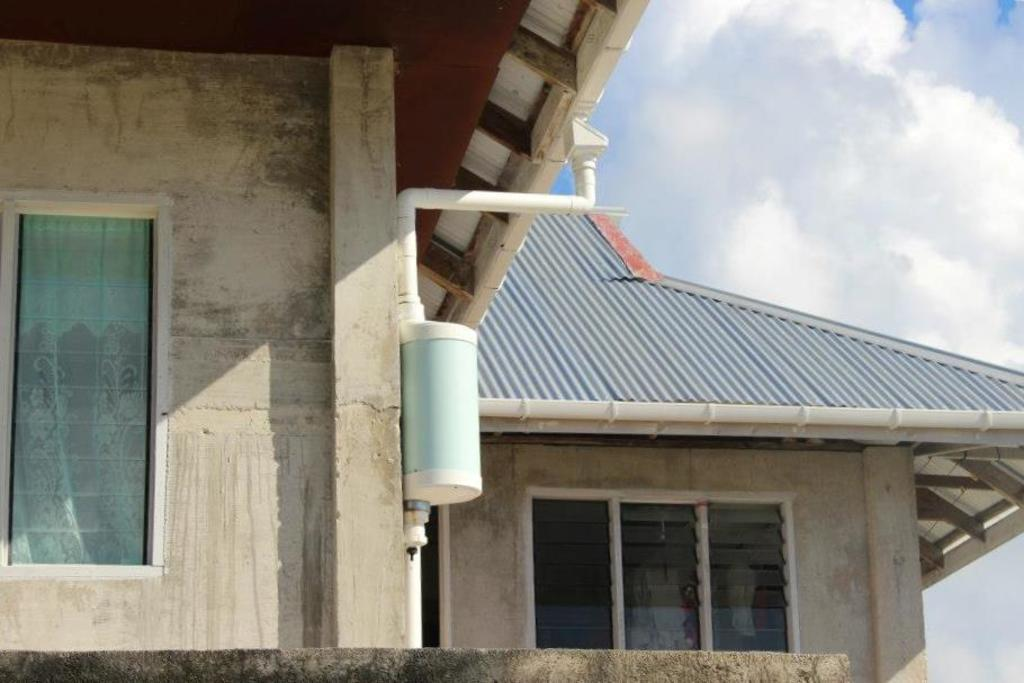What type of structure is present in the image? There is a house in the image. What feature of the house is visible in the image? The house has windows. What part of the natural environment can be seen in the image? The sky is visible in the image. Based on the visibility of the sky, what time of day might the image have been taken? The image was likely taken during the day. How many trees are visible in the image? There are no trees visible in the image; it only features a house and the sky. What type of note is attached to the house in the image? There is no note attached to the house in the image. 